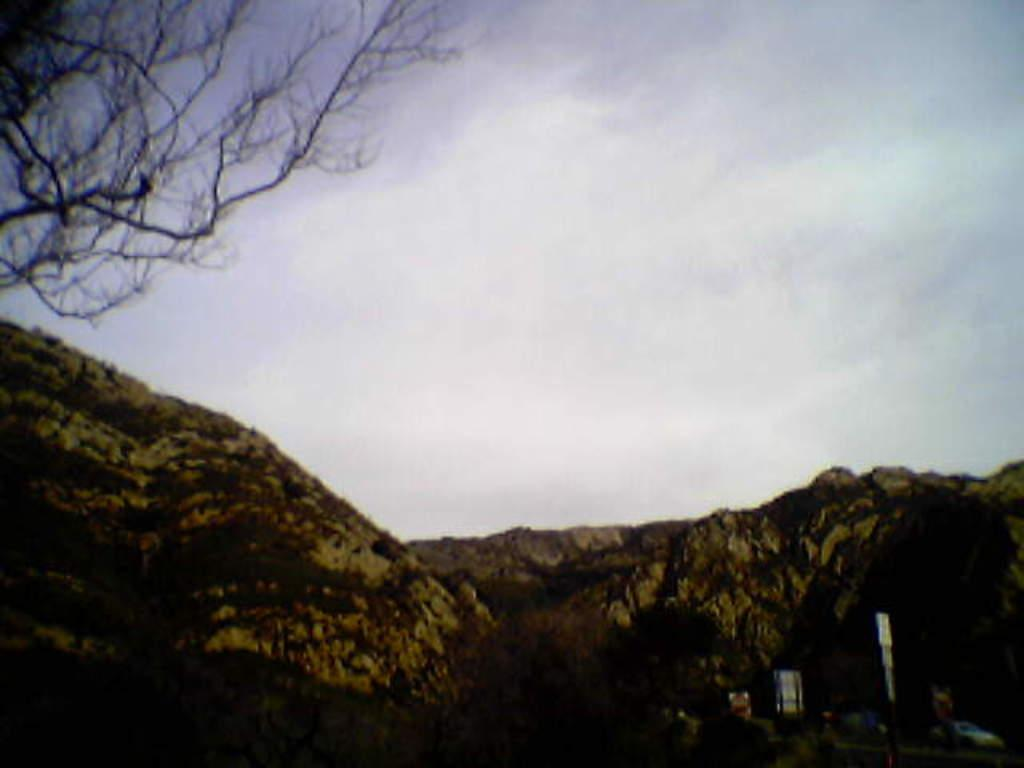What geographical feature is located in the center of the image? There are hills in the center of the image. What type of vegetation can be seen on the left side of the image? There is a tree on the left side of the image. What is visible in the background of the image? The sky is visible in the background of the image. What subject are the friends teaching in the image? There are no friends or teaching activity present in the image. What type of cloud can be seen in the image? The provided facts do not mention any clouds in the image, so we cannot determine the type of cloud. 